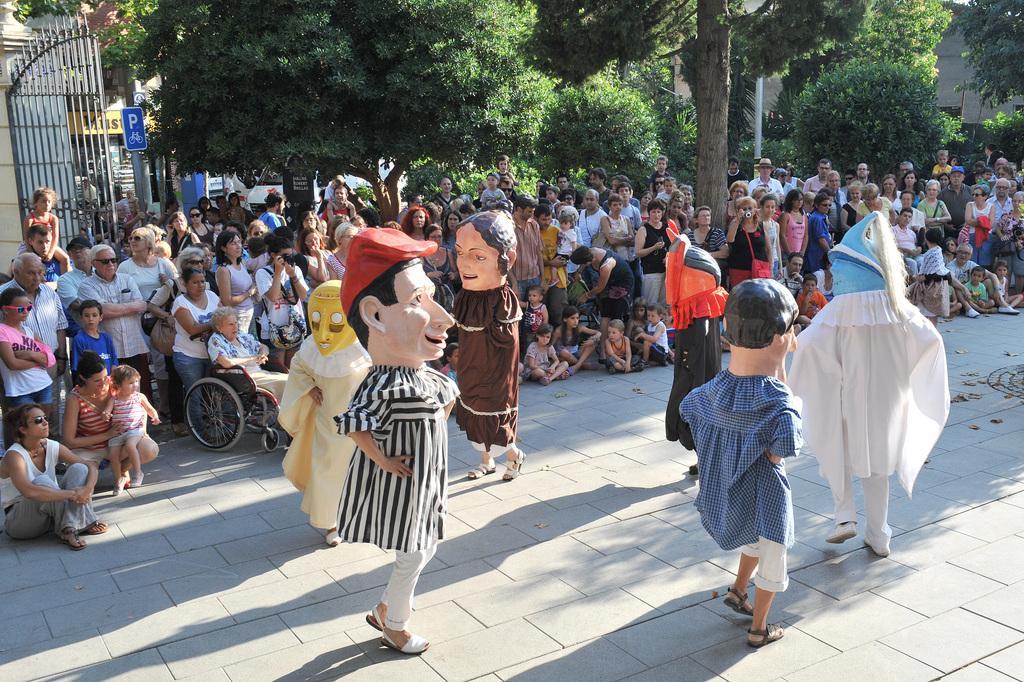How would you summarize this image in a sentence or two? As we can see in the image there are statues, few people here and there, wheel chair, gate, trees and houses. 